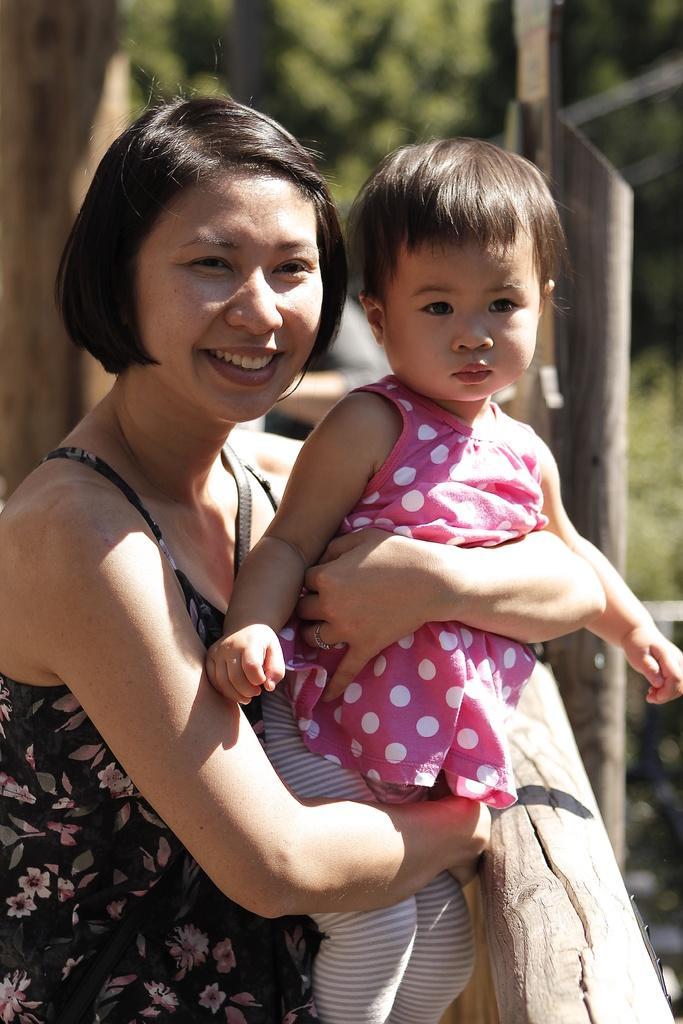Please provide a concise description of this image. Here we can see a woman holding a kid with her hands and she is smiling. There is a blur background with greenery. 